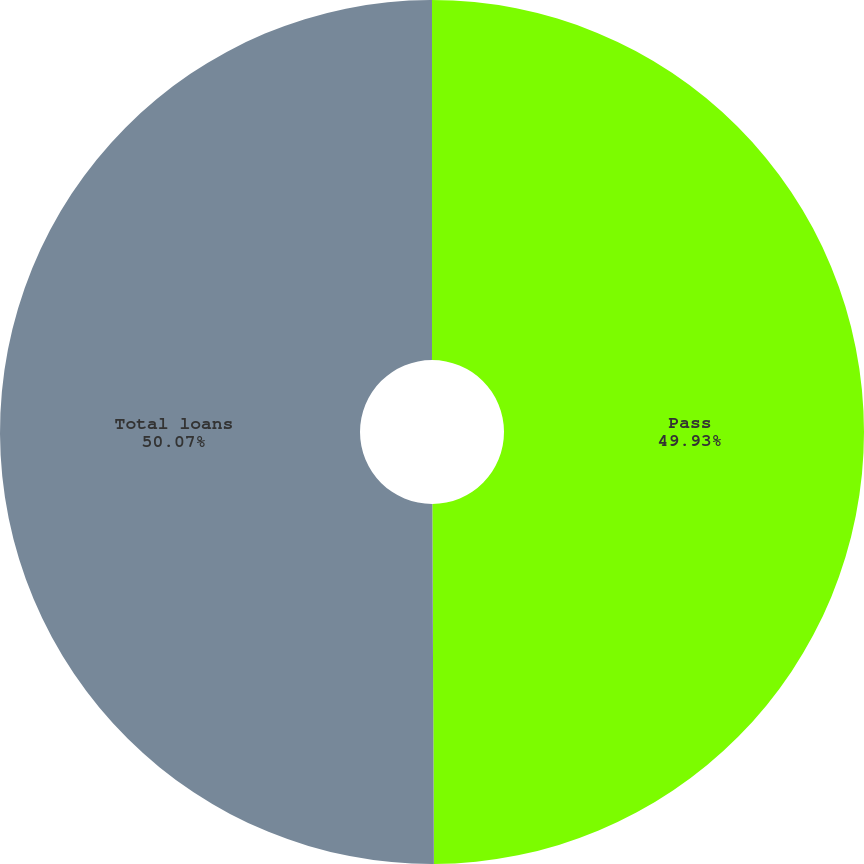Convert chart to OTSL. <chart><loc_0><loc_0><loc_500><loc_500><pie_chart><fcel>Pass<fcel>Total loans<nl><fcel>49.93%<fcel>50.07%<nl></chart> 